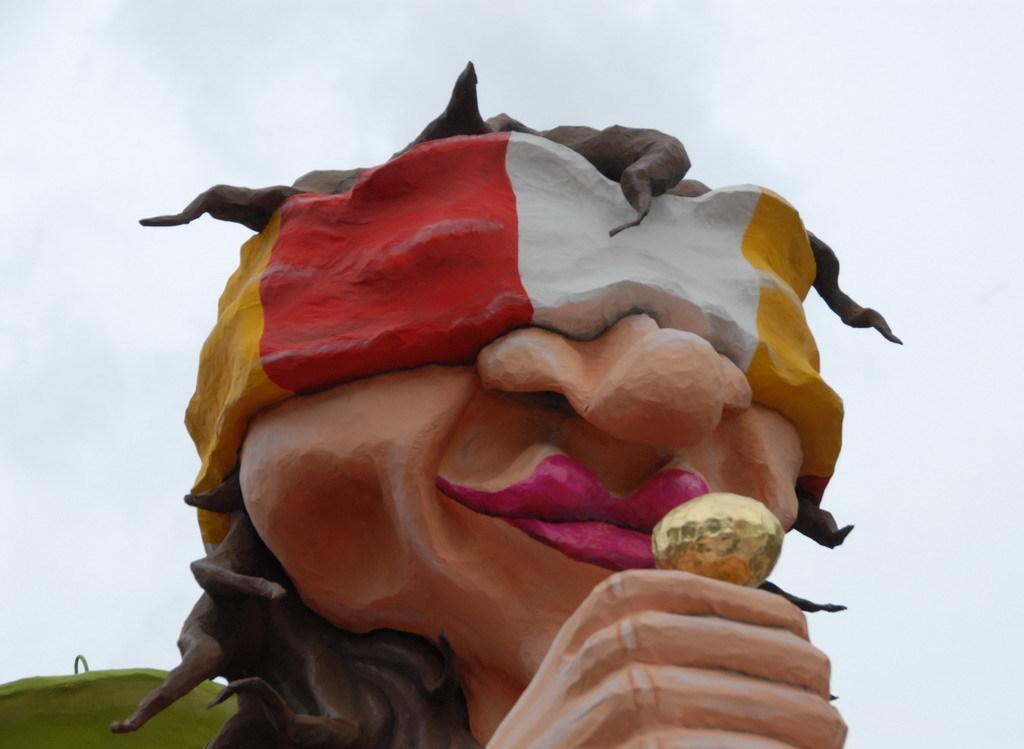In one or two sentences, can you explain what this image depicts? In this image we can see a statue. In the background, we can see the sky. 